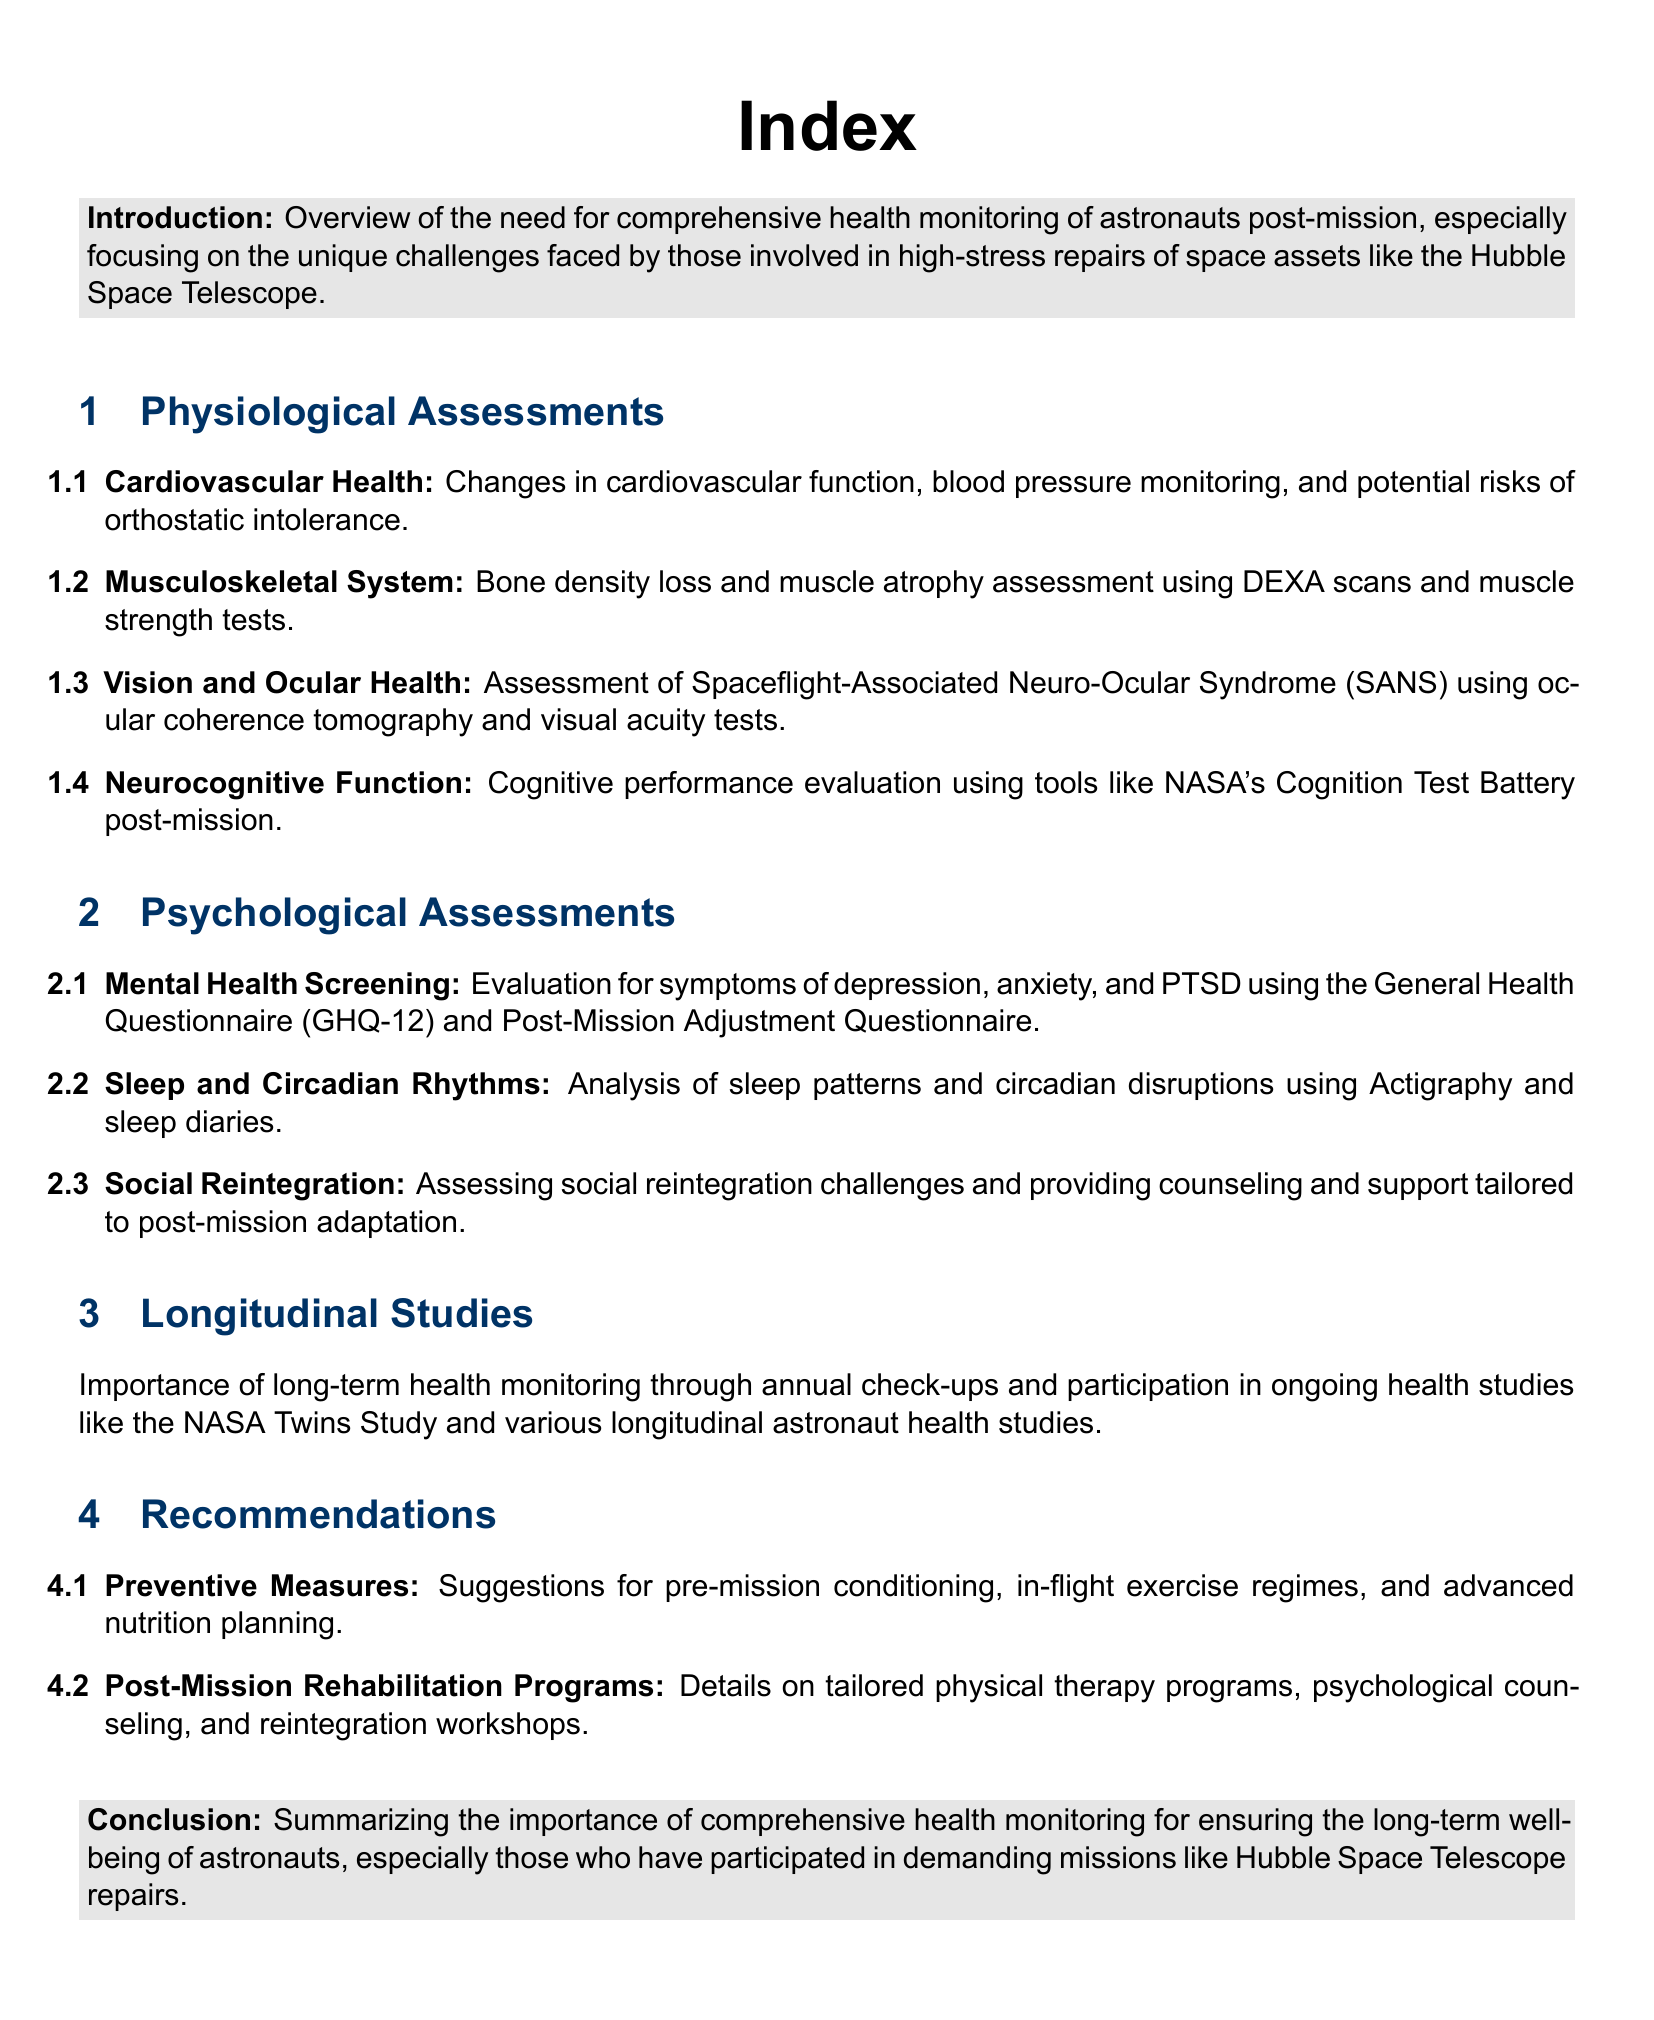what is the title of the report? The title provides the topic of the document, which is the index of a health monitoring report.
Answer: Index how many sections are there in the document? The document contains four main sections, excluding the introduction and conclusion.
Answer: Four what is assessed under cardiovascular health? This information outlines the aspects of cardiovascular health that are evaluated post-mission.
Answer: Changes in cardiovascular function, blood pressure monitoring, and potential risks of orthostatic intolerance what screening tool is used for mental health evaluation? This question refers to the specific tool mentioned in the document for assessing mental health post-mission.
Answer: General Health Questionnaire (GHQ-12) what does SANS stand for? This question is about the acronym used in the context of vision and ocular health.
Answer: Spaceflight-Associated Neuro-Ocular Syndrome what are the long-term health monitoring studies mentioned? This question requires a synthesis of the information provided about ongoing health studies for astronauts.
Answer: NASA Twins Study and various longitudinal astronaut health studies how many recommendations are there? This question inquires about the total number of recommendations provided in the document.
Answer: Two which section covers social reintegration challenges? This defines where in the document the topic of social reintegration is discussed.
Answer: Psychological Assessments 